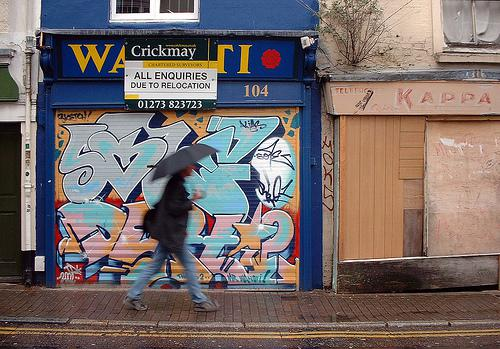Question: what is the person holding?
Choices:
A. A cane.
B. An umbrella.
C. A golf club.
D. A stop sign.
Answer with the letter. Answer: B Question: who is holding the umbrella?
Choices:
A. The woman.
B. The man.
C. The child.
D. The person.
Answer with the letter. Answer: D Question: where is this taken?
Choices:
A. A city street.
B. A restaurant.
C. A beach.
D. A forest path.
Answer with the letter. Answer: A Question: why does the person have an umbrella?
Choices:
A. For shade.
B. It is raining.
C. Considering a purchase.
D. Traditional costume.
Answer with the letter. Answer: B 